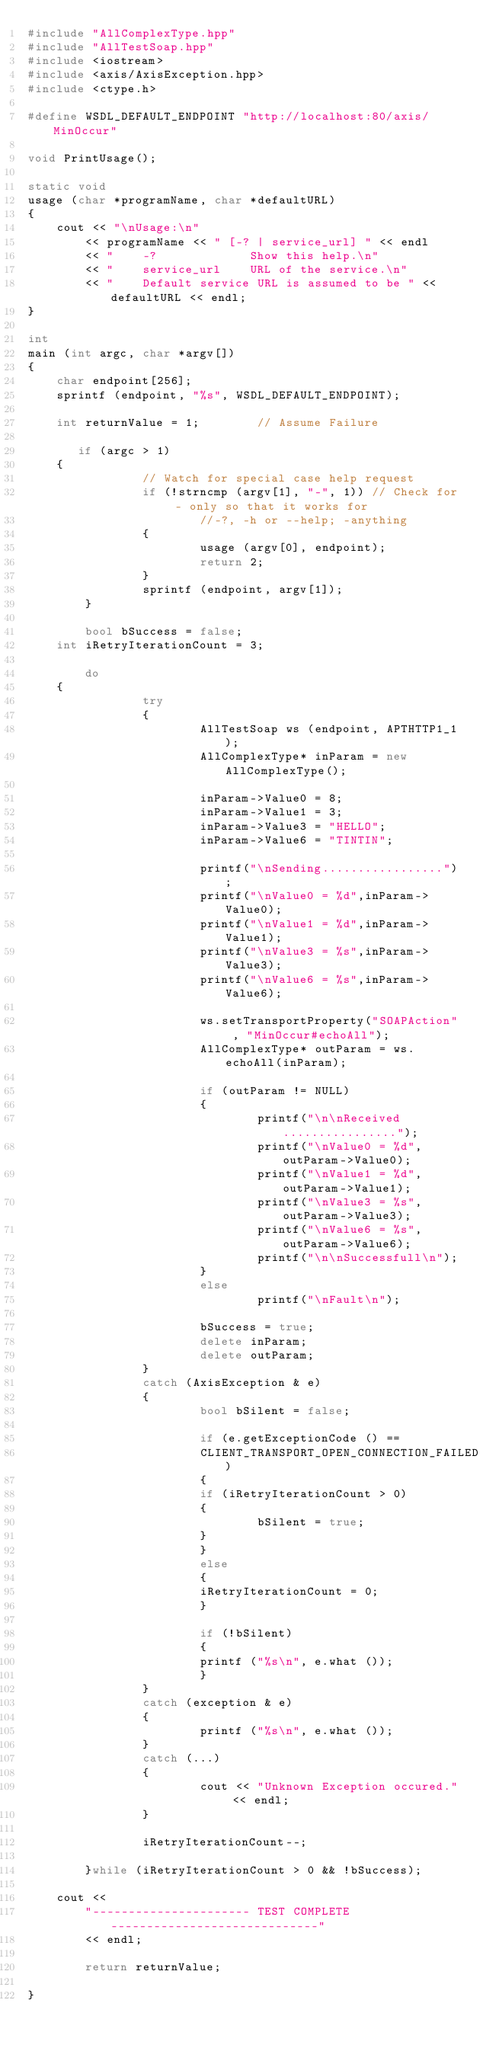<code> <loc_0><loc_0><loc_500><loc_500><_C++_>#include "AllComplexType.hpp"
#include "AllTestSoap.hpp"
#include <iostream>
#include <axis/AxisException.hpp>
#include <ctype.h>

#define WSDL_DEFAULT_ENDPOINT "http://localhost:80/axis/MinOccur"

void PrintUsage();

static void
usage (char *programName, char *defaultURL)
{
    cout << "\nUsage:\n"
        << programName << " [-? | service_url] " << endl
        << "    -?             Show this help.\n"
        << "    service_url    URL of the service.\n"
        << "    Default service URL is assumed to be " << defaultURL << endl;
}

int
main (int argc, char *argv[])
{
    char endpoint[256];
    sprintf (endpoint, "%s", WSDL_DEFAULT_ENDPOINT);

    int returnValue = 1;        // Assume Failure

       if (argc > 1)
    {
                // Watch for special case help request
                if (!strncmp (argv[1], "-", 1)) // Check for - only so that it works for
                        //-?, -h or --help; -anything
                {
                        usage (argv[0], endpoint);
                        return 2;
                }
                sprintf (endpoint, argv[1]);
        }

        bool bSuccess = false;
    int iRetryIterationCount = 3;

        do
    {
                try
                {
                        AllTestSoap ws (endpoint, APTHTTP1_1);
                        AllComplexType* inParam = new AllComplexType();

                        inParam->Value0 = 8;
                        inParam->Value1 = 3;
                        inParam->Value3 = "HELLO";
                        inParam->Value6 = "TINTIN";

                        printf("\nSending.................");
                        printf("\nValue0 = %d",inParam->Value0);
                        printf("\nValue1 = %d",inParam->Value1);
                        printf("\nValue3 = %s",inParam->Value3);
                        printf("\nValue6 = %s",inParam->Value6);
                        
                        ws.setTransportProperty("SOAPAction" , "MinOccur#echoAll");
                        AllComplexType* outParam = ws.echoAll(inParam);

                        if (outParam != NULL)
                        {
                                printf("\n\nReceived................");
                                printf("\nValue0 = %d",outParam->Value0);
                                printf("\nValue1 = %d",outParam->Value1);
                                printf("\nValue3 = %s",outParam->Value3);
                                printf("\nValue6 = %s",outParam->Value6);
                                printf("\n\nSuccessfull\n");
                        }
                        else
                                printf("\nFault\n");

                        bSuccess = true;
                        delete inParam;
                        delete outParam;
                }
                catch (AxisException & e)
                {
                        bool bSilent = false;

                        if (e.getExceptionCode () ==
                        CLIENT_TRANSPORT_OPEN_CONNECTION_FAILED)
                        {
                        if (iRetryIterationCount > 0)
                        {
                                bSilent = true;
                        }
                        }
                        else
                        {
                        iRetryIterationCount = 0;
                        }

                        if (!bSilent)
                        {
                        printf ("%s\n", e.what ());
                        }
                }
                catch (exception & e)
                {
                        printf ("%s\n", e.what ());
                }       
                catch (...)
                {
                        cout << "Unknown Exception occured." << endl;
                }

                iRetryIterationCount--;

        }while (iRetryIterationCount > 0 && !bSuccess);

    cout <<
        "---------------------- TEST COMPLETE -----------------------------"
        << endl;
    
        return returnValue;

}
</code> 